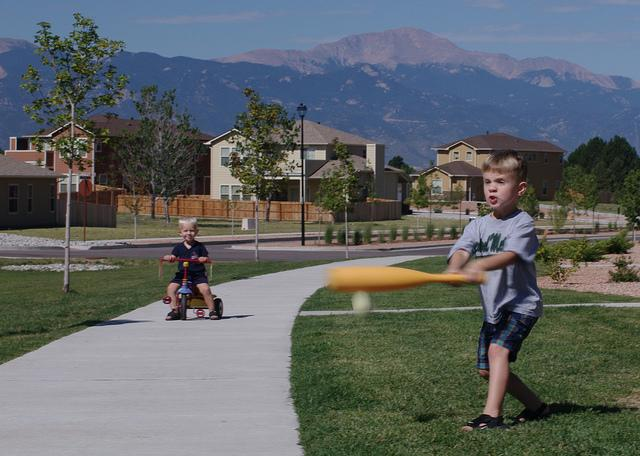What is the child travelling on? tricycle 